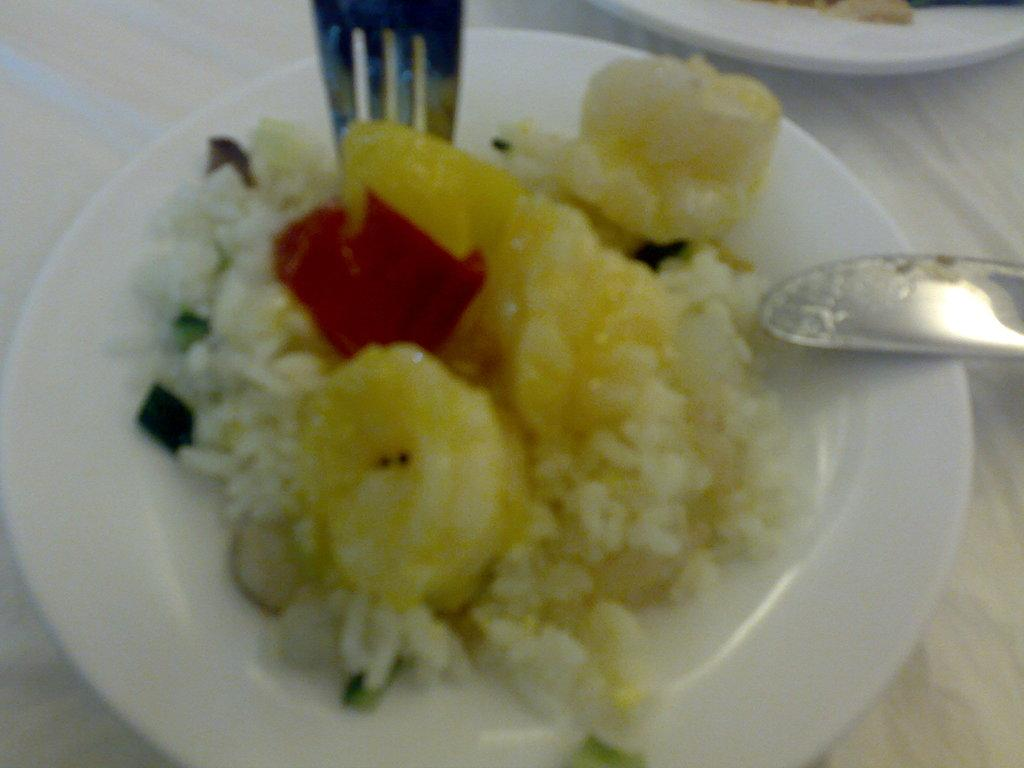What type of furniture is present in the image? There is a table in the image. What is covering the table? There is a cloth on the table. What is placed on top of the table? There is a plate on the table. What is on the plate? There is a food item on the plate. What utensils are present on the plate? There are spoons on the plate. Can you see the coastline in the image? There is no coastline visible in the image; it features a table with a cloth, plate, food item, and spoons. 